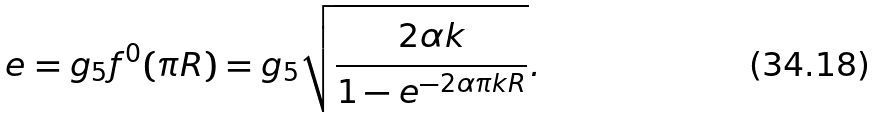<formula> <loc_0><loc_0><loc_500><loc_500>e = g _ { 5 } f ^ { 0 } ( \pi R ) = g _ { 5 } \sqrt { \frac { 2 \alpha k } { 1 - e ^ { - 2 \alpha \pi k R } } } .</formula> 